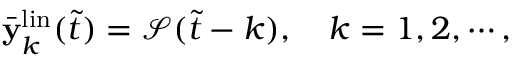Convert formula to latex. <formula><loc_0><loc_0><loc_500><loc_500>\begin{array} { r } { \bar { y } _ { k } ^ { l i n } ( \tilde { t } ) = \mathcal { S } ( \tilde { t } - k ) , \quad k = 1 , 2 , \cdots , } \end{array}</formula> 